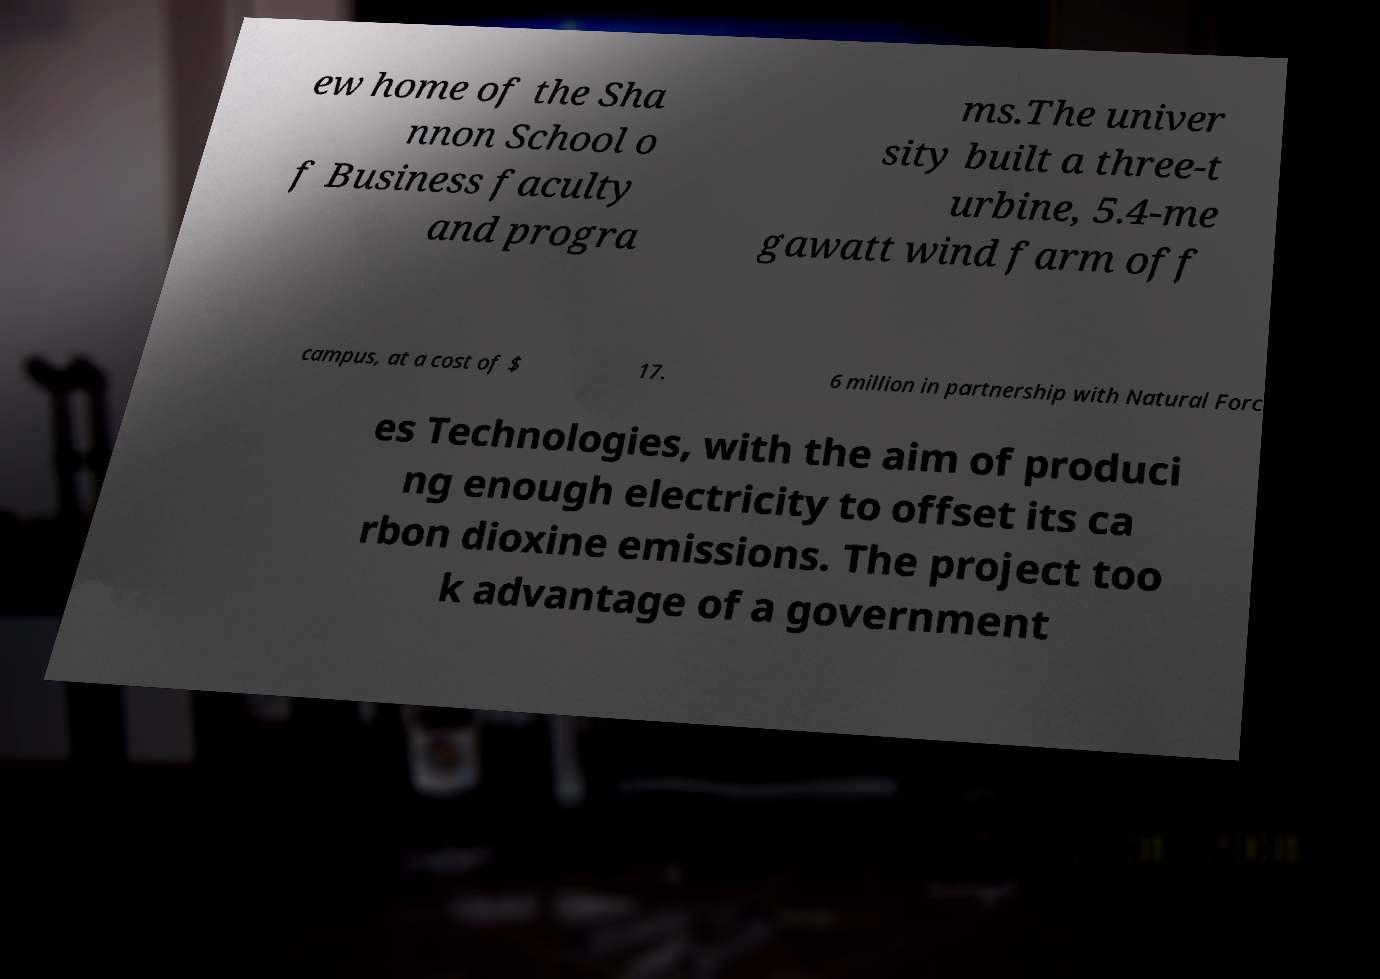I need the written content from this picture converted into text. Can you do that? ew home of the Sha nnon School o f Business faculty and progra ms.The univer sity built a three-t urbine, 5.4-me gawatt wind farm off campus, at a cost of $ 17. 6 million in partnership with Natural Forc es Technologies, with the aim of produci ng enough electricity to offset its ca rbon dioxine emissions. The project too k advantage of a government 